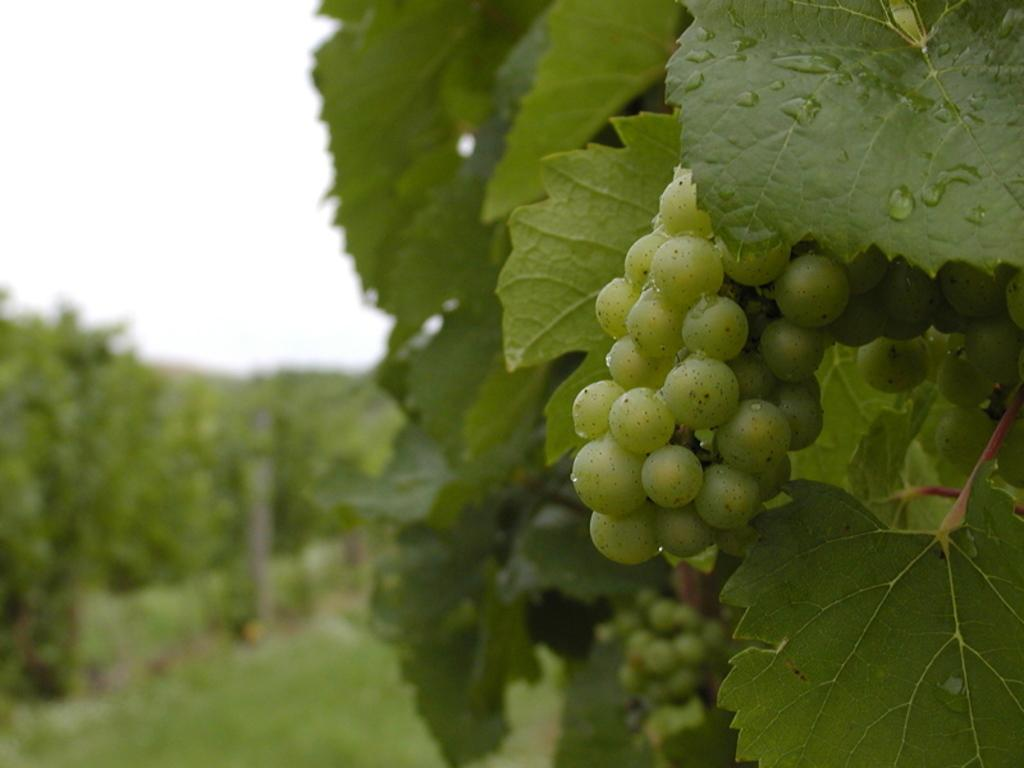What objects can be seen on the right side of the image? There are leaves and grapes on the right side of the image. How would you describe the background of the image? The background of the image is blurred. What natural elements can be seen in the background? There are trees and the sky visible in the background. How does the cook feel about the straw in the image? There is no cook or straw present in the image, so this question cannot be answered. 